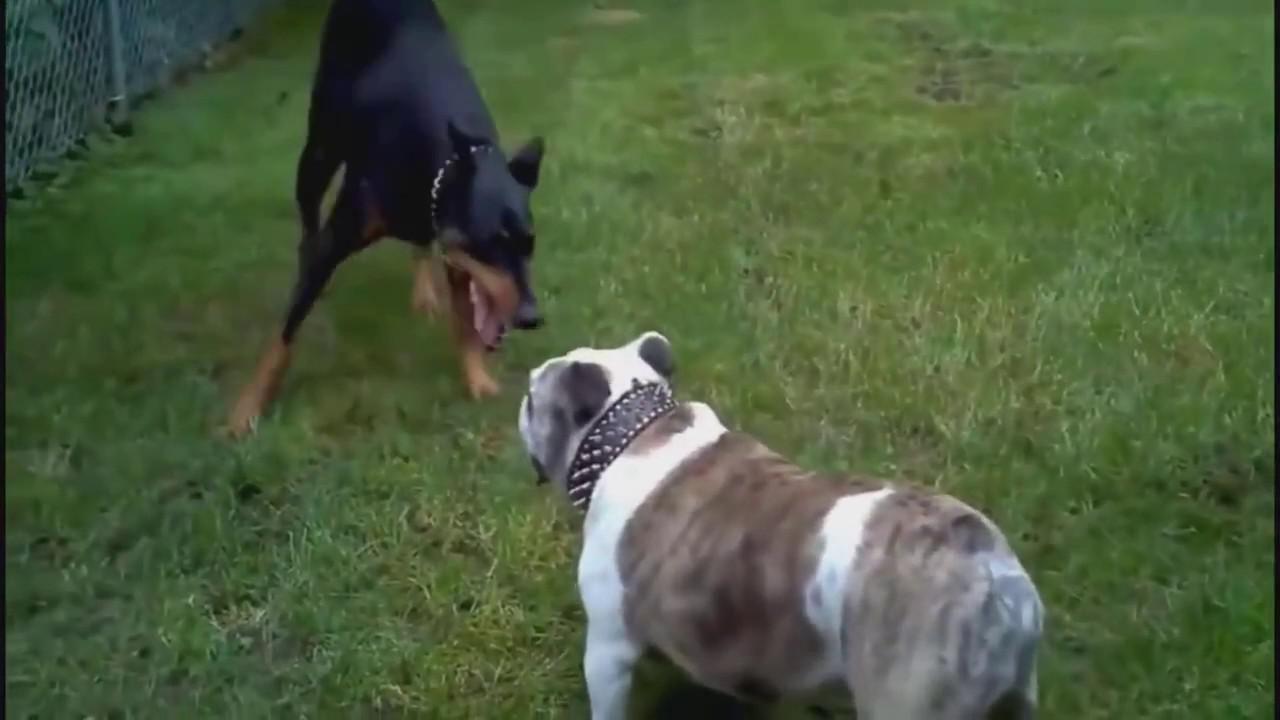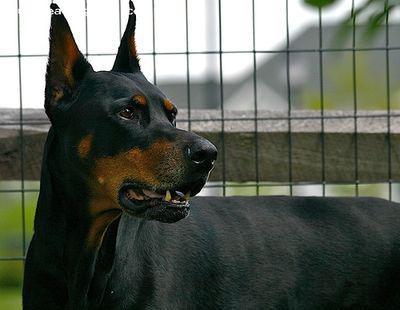The first image is the image on the left, the second image is the image on the right. For the images displayed, is the sentence "The right image contains at least two dogs." factually correct? Answer yes or no. No. 